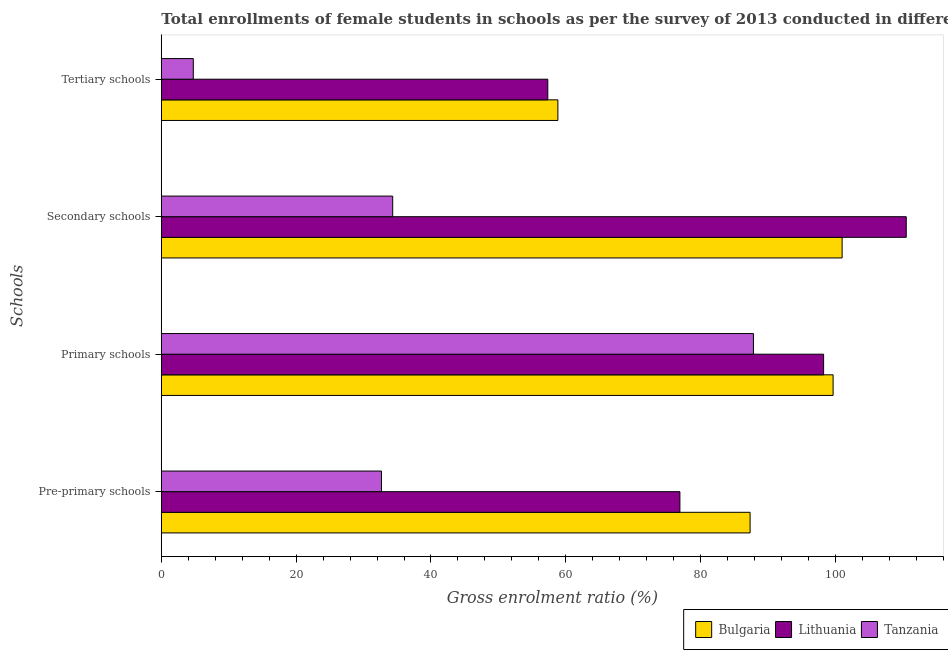How many different coloured bars are there?
Offer a terse response. 3. How many groups of bars are there?
Your response must be concise. 4. Are the number of bars on each tick of the Y-axis equal?
Keep it short and to the point. Yes. How many bars are there on the 1st tick from the bottom?
Ensure brevity in your answer.  3. What is the label of the 3rd group of bars from the top?
Make the answer very short. Primary schools. What is the gross enrolment ratio(female) in secondary schools in Tanzania?
Provide a short and direct response. 34.33. Across all countries, what is the maximum gross enrolment ratio(female) in tertiary schools?
Ensure brevity in your answer.  58.83. Across all countries, what is the minimum gross enrolment ratio(female) in tertiary schools?
Make the answer very short. 4.74. In which country was the gross enrolment ratio(female) in tertiary schools minimum?
Your answer should be very brief. Tanzania. What is the total gross enrolment ratio(female) in primary schools in the graph?
Your response must be concise. 285.74. What is the difference between the gross enrolment ratio(female) in tertiary schools in Tanzania and that in Lithuania?
Provide a succinct answer. -52.59. What is the difference between the gross enrolment ratio(female) in primary schools in Tanzania and the gross enrolment ratio(female) in secondary schools in Bulgaria?
Offer a terse response. -13.16. What is the average gross enrolment ratio(female) in tertiary schools per country?
Provide a short and direct response. 40.3. What is the difference between the gross enrolment ratio(female) in primary schools and gross enrolment ratio(female) in secondary schools in Lithuania?
Provide a short and direct response. -12.26. In how many countries, is the gross enrolment ratio(female) in pre-primary schools greater than 96 %?
Provide a short and direct response. 0. What is the ratio of the gross enrolment ratio(female) in tertiary schools in Bulgaria to that in Lithuania?
Give a very brief answer. 1.03. What is the difference between the highest and the second highest gross enrolment ratio(female) in primary schools?
Your response must be concise. 1.41. What is the difference between the highest and the lowest gross enrolment ratio(female) in tertiary schools?
Provide a succinct answer. 54.08. What does the 1st bar from the top in Primary schools represents?
Offer a very short reply. Tanzania. What does the 2nd bar from the bottom in Primary schools represents?
Offer a terse response. Lithuania. Is it the case that in every country, the sum of the gross enrolment ratio(female) in pre-primary schools and gross enrolment ratio(female) in primary schools is greater than the gross enrolment ratio(female) in secondary schools?
Your response must be concise. Yes. How many bars are there?
Your response must be concise. 12. Are all the bars in the graph horizontal?
Make the answer very short. Yes. Are the values on the major ticks of X-axis written in scientific E-notation?
Make the answer very short. No. How are the legend labels stacked?
Ensure brevity in your answer.  Horizontal. What is the title of the graph?
Provide a succinct answer. Total enrollments of female students in schools as per the survey of 2013 conducted in different countries. Does "Arab World" appear as one of the legend labels in the graph?
Ensure brevity in your answer.  No. What is the label or title of the Y-axis?
Keep it short and to the point. Schools. What is the Gross enrolment ratio (%) of Bulgaria in Pre-primary schools?
Offer a terse response. 87.34. What is the Gross enrolment ratio (%) of Lithuania in Pre-primary schools?
Provide a succinct answer. 76.93. What is the Gross enrolment ratio (%) of Tanzania in Pre-primary schools?
Make the answer very short. 32.66. What is the Gross enrolment ratio (%) of Bulgaria in Primary schools?
Provide a succinct answer. 99.66. What is the Gross enrolment ratio (%) of Lithuania in Primary schools?
Your response must be concise. 98.25. What is the Gross enrolment ratio (%) of Tanzania in Primary schools?
Offer a very short reply. 87.84. What is the Gross enrolment ratio (%) in Bulgaria in Secondary schools?
Your answer should be very brief. 100.99. What is the Gross enrolment ratio (%) of Lithuania in Secondary schools?
Ensure brevity in your answer.  110.51. What is the Gross enrolment ratio (%) of Tanzania in Secondary schools?
Give a very brief answer. 34.33. What is the Gross enrolment ratio (%) of Bulgaria in Tertiary schools?
Make the answer very short. 58.83. What is the Gross enrolment ratio (%) of Lithuania in Tertiary schools?
Your answer should be very brief. 57.33. What is the Gross enrolment ratio (%) of Tanzania in Tertiary schools?
Make the answer very short. 4.74. Across all Schools, what is the maximum Gross enrolment ratio (%) of Bulgaria?
Provide a short and direct response. 100.99. Across all Schools, what is the maximum Gross enrolment ratio (%) of Lithuania?
Your response must be concise. 110.51. Across all Schools, what is the maximum Gross enrolment ratio (%) in Tanzania?
Offer a terse response. 87.84. Across all Schools, what is the minimum Gross enrolment ratio (%) of Bulgaria?
Provide a succinct answer. 58.83. Across all Schools, what is the minimum Gross enrolment ratio (%) in Lithuania?
Give a very brief answer. 57.33. Across all Schools, what is the minimum Gross enrolment ratio (%) of Tanzania?
Offer a terse response. 4.74. What is the total Gross enrolment ratio (%) of Bulgaria in the graph?
Keep it short and to the point. 346.82. What is the total Gross enrolment ratio (%) in Lithuania in the graph?
Provide a succinct answer. 343.01. What is the total Gross enrolment ratio (%) of Tanzania in the graph?
Provide a succinct answer. 159.56. What is the difference between the Gross enrolment ratio (%) in Bulgaria in Pre-primary schools and that in Primary schools?
Make the answer very short. -12.31. What is the difference between the Gross enrolment ratio (%) of Lithuania in Pre-primary schools and that in Primary schools?
Your answer should be very brief. -21.32. What is the difference between the Gross enrolment ratio (%) of Tanzania in Pre-primary schools and that in Primary schools?
Your answer should be compact. -55.18. What is the difference between the Gross enrolment ratio (%) of Bulgaria in Pre-primary schools and that in Secondary schools?
Provide a succinct answer. -13.65. What is the difference between the Gross enrolment ratio (%) in Lithuania in Pre-primary schools and that in Secondary schools?
Your response must be concise. -33.58. What is the difference between the Gross enrolment ratio (%) of Tanzania in Pre-primary schools and that in Secondary schools?
Make the answer very short. -1.67. What is the difference between the Gross enrolment ratio (%) of Bulgaria in Pre-primary schools and that in Tertiary schools?
Keep it short and to the point. 28.51. What is the difference between the Gross enrolment ratio (%) of Lithuania in Pre-primary schools and that in Tertiary schools?
Offer a terse response. 19.6. What is the difference between the Gross enrolment ratio (%) of Tanzania in Pre-primary schools and that in Tertiary schools?
Your answer should be very brief. 27.91. What is the difference between the Gross enrolment ratio (%) of Bulgaria in Primary schools and that in Secondary schools?
Keep it short and to the point. -1.34. What is the difference between the Gross enrolment ratio (%) of Lithuania in Primary schools and that in Secondary schools?
Your response must be concise. -12.26. What is the difference between the Gross enrolment ratio (%) in Tanzania in Primary schools and that in Secondary schools?
Provide a short and direct response. 53.51. What is the difference between the Gross enrolment ratio (%) in Bulgaria in Primary schools and that in Tertiary schools?
Provide a short and direct response. 40.83. What is the difference between the Gross enrolment ratio (%) in Lithuania in Primary schools and that in Tertiary schools?
Ensure brevity in your answer.  40.92. What is the difference between the Gross enrolment ratio (%) in Tanzania in Primary schools and that in Tertiary schools?
Provide a succinct answer. 83.09. What is the difference between the Gross enrolment ratio (%) of Bulgaria in Secondary schools and that in Tertiary schools?
Your answer should be compact. 42.17. What is the difference between the Gross enrolment ratio (%) in Lithuania in Secondary schools and that in Tertiary schools?
Offer a terse response. 53.17. What is the difference between the Gross enrolment ratio (%) in Tanzania in Secondary schools and that in Tertiary schools?
Offer a terse response. 29.58. What is the difference between the Gross enrolment ratio (%) in Bulgaria in Pre-primary schools and the Gross enrolment ratio (%) in Lithuania in Primary schools?
Give a very brief answer. -10.91. What is the difference between the Gross enrolment ratio (%) in Bulgaria in Pre-primary schools and the Gross enrolment ratio (%) in Tanzania in Primary schools?
Make the answer very short. -0.49. What is the difference between the Gross enrolment ratio (%) of Lithuania in Pre-primary schools and the Gross enrolment ratio (%) of Tanzania in Primary schools?
Ensure brevity in your answer.  -10.91. What is the difference between the Gross enrolment ratio (%) in Bulgaria in Pre-primary schools and the Gross enrolment ratio (%) in Lithuania in Secondary schools?
Offer a very short reply. -23.16. What is the difference between the Gross enrolment ratio (%) of Bulgaria in Pre-primary schools and the Gross enrolment ratio (%) of Tanzania in Secondary schools?
Offer a very short reply. 53.02. What is the difference between the Gross enrolment ratio (%) in Lithuania in Pre-primary schools and the Gross enrolment ratio (%) in Tanzania in Secondary schools?
Give a very brief answer. 42.6. What is the difference between the Gross enrolment ratio (%) in Bulgaria in Pre-primary schools and the Gross enrolment ratio (%) in Lithuania in Tertiary schools?
Keep it short and to the point. 30.01. What is the difference between the Gross enrolment ratio (%) in Bulgaria in Pre-primary schools and the Gross enrolment ratio (%) in Tanzania in Tertiary schools?
Your answer should be compact. 82.6. What is the difference between the Gross enrolment ratio (%) of Lithuania in Pre-primary schools and the Gross enrolment ratio (%) of Tanzania in Tertiary schools?
Your answer should be compact. 72.18. What is the difference between the Gross enrolment ratio (%) of Bulgaria in Primary schools and the Gross enrolment ratio (%) of Lithuania in Secondary schools?
Offer a very short reply. -10.85. What is the difference between the Gross enrolment ratio (%) of Bulgaria in Primary schools and the Gross enrolment ratio (%) of Tanzania in Secondary schools?
Provide a succinct answer. 65.33. What is the difference between the Gross enrolment ratio (%) in Lithuania in Primary schools and the Gross enrolment ratio (%) in Tanzania in Secondary schools?
Your answer should be compact. 63.92. What is the difference between the Gross enrolment ratio (%) in Bulgaria in Primary schools and the Gross enrolment ratio (%) in Lithuania in Tertiary schools?
Give a very brief answer. 42.32. What is the difference between the Gross enrolment ratio (%) of Bulgaria in Primary schools and the Gross enrolment ratio (%) of Tanzania in Tertiary schools?
Make the answer very short. 94.91. What is the difference between the Gross enrolment ratio (%) of Lithuania in Primary schools and the Gross enrolment ratio (%) of Tanzania in Tertiary schools?
Your answer should be very brief. 93.5. What is the difference between the Gross enrolment ratio (%) in Bulgaria in Secondary schools and the Gross enrolment ratio (%) in Lithuania in Tertiary schools?
Provide a short and direct response. 43.66. What is the difference between the Gross enrolment ratio (%) of Bulgaria in Secondary schools and the Gross enrolment ratio (%) of Tanzania in Tertiary schools?
Ensure brevity in your answer.  96.25. What is the difference between the Gross enrolment ratio (%) in Lithuania in Secondary schools and the Gross enrolment ratio (%) in Tanzania in Tertiary schools?
Provide a short and direct response. 105.76. What is the average Gross enrolment ratio (%) of Bulgaria per Schools?
Offer a terse response. 86.7. What is the average Gross enrolment ratio (%) in Lithuania per Schools?
Offer a terse response. 85.75. What is the average Gross enrolment ratio (%) of Tanzania per Schools?
Offer a terse response. 39.89. What is the difference between the Gross enrolment ratio (%) in Bulgaria and Gross enrolment ratio (%) in Lithuania in Pre-primary schools?
Provide a succinct answer. 10.41. What is the difference between the Gross enrolment ratio (%) in Bulgaria and Gross enrolment ratio (%) in Tanzania in Pre-primary schools?
Offer a terse response. 54.68. What is the difference between the Gross enrolment ratio (%) in Lithuania and Gross enrolment ratio (%) in Tanzania in Pre-primary schools?
Your answer should be compact. 44.27. What is the difference between the Gross enrolment ratio (%) in Bulgaria and Gross enrolment ratio (%) in Lithuania in Primary schools?
Make the answer very short. 1.41. What is the difference between the Gross enrolment ratio (%) in Bulgaria and Gross enrolment ratio (%) in Tanzania in Primary schools?
Make the answer very short. 11.82. What is the difference between the Gross enrolment ratio (%) in Lithuania and Gross enrolment ratio (%) in Tanzania in Primary schools?
Your response must be concise. 10.41. What is the difference between the Gross enrolment ratio (%) of Bulgaria and Gross enrolment ratio (%) of Lithuania in Secondary schools?
Keep it short and to the point. -9.51. What is the difference between the Gross enrolment ratio (%) in Bulgaria and Gross enrolment ratio (%) in Tanzania in Secondary schools?
Your answer should be very brief. 66.67. What is the difference between the Gross enrolment ratio (%) of Lithuania and Gross enrolment ratio (%) of Tanzania in Secondary schools?
Offer a very short reply. 76.18. What is the difference between the Gross enrolment ratio (%) in Bulgaria and Gross enrolment ratio (%) in Lithuania in Tertiary schools?
Make the answer very short. 1.5. What is the difference between the Gross enrolment ratio (%) in Bulgaria and Gross enrolment ratio (%) in Tanzania in Tertiary schools?
Your answer should be very brief. 54.08. What is the difference between the Gross enrolment ratio (%) of Lithuania and Gross enrolment ratio (%) of Tanzania in Tertiary schools?
Provide a succinct answer. 52.59. What is the ratio of the Gross enrolment ratio (%) in Bulgaria in Pre-primary schools to that in Primary schools?
Offer a terse response. 0.88. What is the ratio of the Gross enrolment ratio (%) in Lithuania in Pre-primary schools to that in Primary schools?
Make the answer very short. 0.78. What is the ratio of the Gross enrolment ratio (%) in Tanzania in Pre-primary schools to that in Primary schools?
Keep it short and to the point. 0.37. What is the ratio of the Gross enrolment ratio (%) in Bulgaria in Pre-primary schools to that in Secondary schools?
Your response must be concise. 0.86. What is the ratio of the Gross enrolment ratio (%) in Lithuania in Pre-primary schools to that in Secondary schools?
Offer a terse response. 0.7. What is the ratio of the Gross enrolment ratio (%) of Tanzania in Pre-primary schools to that in Secondary schools?
Keep it short and to the point. 0.95. What is the ratio of the Gross enrolment ratio (%) in Bulgaria in Pre-primary schools to that in Tertiary schools?
Keep it short and to the point. 1.48. What is the ratio of the Gross enrolment ratio (%) of Lithuania in Pre-primary schools to that in Tertiary schools?
Keep it short and to the point. 1.34. What is the ratio of the Gross enrolment ratio (%) in Tanzania in Pre-primary schools to that in Tertiary schools?
Offer a very short reply. 6.88. What is the ratio of the Gross enrolment ratio (%) of Bulgaria in Primary schools to that in Secondary schools?
Your response must be concise. 0.99. What is the ratio of the Gross enrolment ratio (%) of Lithuania in Primary schools to that in Secondary schools?
Your answer should be very brief. 0.89. What is the ratio of the Gross enrolment ratio (%) in Tanzania in Primary schools to that in Secondary schools?
Provide a succinct answer. 2.56. What is the ratio of the Gross enrolment ratio (%) of Bulgaria in Primary schools to that in Tertiary schools?
Offer a very short reply. 1.69. What is the ratio of the Gross enrolment ratio (%) in Lithuania in Primary schools to that in Tertiary schools?
Your answer should be very brief. 1.71. What is the ratio of the Gross enrolment ratio (%) of Tanzania in Primary schools to that in Tertiary schools?
Your answer should be compact. 18.52. What is the ratio of the Gross enrolment ratio (%) of Bulgaria in Secondary schools to that in Tertiary schools?
Offer a very short reply. 1.72. What is the ratio of the Gross enrolment ratio (%) of Lithuania in Secondary schools to that in Tertiary schools?
Offer a terse response. 1.93. What is the ratio of the Gross enrolment ratio (%) of Tanzania in Secondary schools to that in Tertiary schools?
Provide a short and direct response. 7.24. What is the difference between the highest and the second highest Gross enrolment ratio (%) of Bulgaria?
Provide a short and direct response. 1.34. What is the difference between the highest and the second highest Gross enrolment ratio (%) of Lithuania?
Offer a terse response. 12.26. What is the difference between the highest and the second highest Gross enrolment ratio (%) of Tanzania?
Make the answer very short. 53.51. What is the difference between the highest and the lowest Gross enrolment ratio (%) in Bulgaria?
Your response must be concise. 42.17. What is the difference between the highest and the lowest Gross enrolment ratio (%) in Lithuania?
Your response must be concise. 53.17. What is the difference between the highest and the lowest Gross enrolment ratio (%) in Tanzania?
Offer a very short reply. 83.09. 